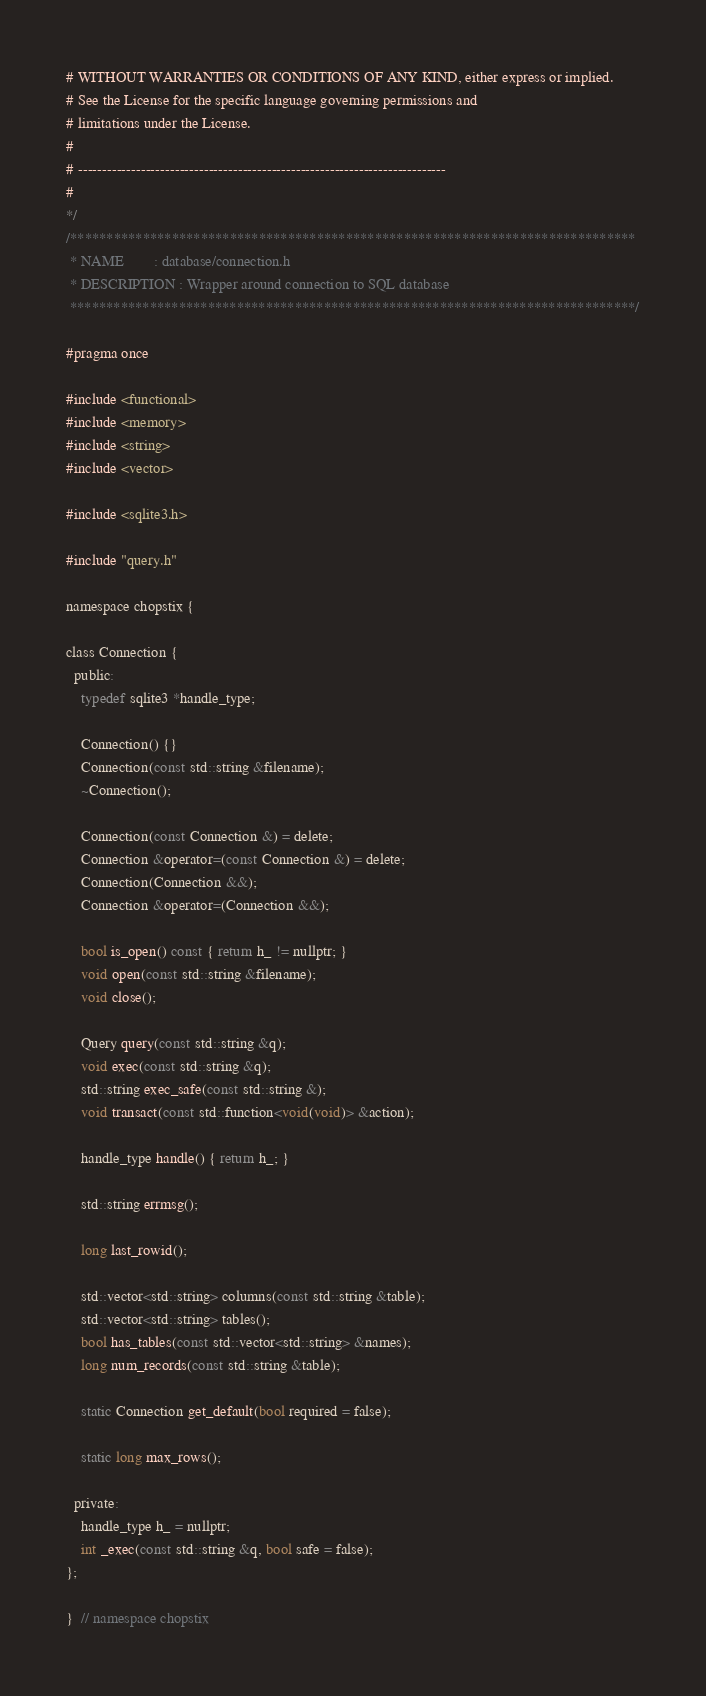Convert code to text. <code><loc_0><loc_0><loc_500><loc_500><_C_># WITHOUT WARRANTIES OR CONDITIONS OF ANY KIND, either express or implied.
# See the License for the specific language governing permissions and
# limitations under the License.
#
# ----------------------------------------------------------------------------
#
*/
/******************************************************************************
 * NAME        : database/connection.h
 * DESCRIPTION : Wrapper around connection to SQL database
 ******************************************************************************/

#pragma once

#include <functional>
#include <memory>
#include <string>
#include <vector>

#include <sqlite3.h>

#include "query.h"

namespace chopstix {

class Connection {
  public:
    typedef sqlite3 *handle_type;

    Connection() {}
    Connection(const std::string &filename);
    ~Connection();

    Connection(const Connection &) = delete;
    Connection &operator=(const Connection &) = delete;
    Connection(Connection &&);
    Connection &operator=(Connection &&);

    bool is_open() const { return h_ != nullptr; }
    void open(const std::string &filename);
    void close();

    Query query(const std::string &q);
    void exec(const std::string &q);
    std::string exec_safe(const std::string &);
    void transact(const std::function<void(void)> &action);

    handle_type handle() { return h_; }

    std::string errmsg();

    long last_rowid();

    std::vector<std::string> columns(const std::string &table);
    std::vector<std::string> tables();
    bool has_tables(const std::vector<std::string> &names);
    long num_records(const std::string &table);

    static Connection get_default(bool required = false);

    static long max_rows();

  private:
    handle_type h_ = nullptr;
    int _exec(const std::string &q, bool safe = false);
};

}  // namespace chopstix
</code> 